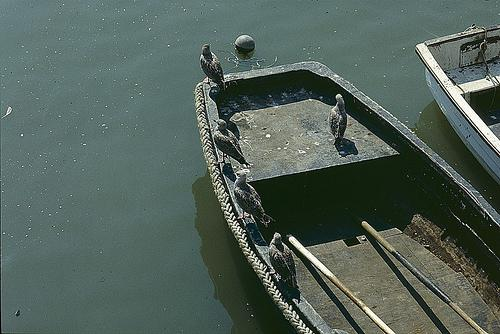Question: what type of vehicle is pictured?
Choices:
A. Boat.
B. Motorcycle.
C. Toyota.
D. Car.
Answer with the letter. Answer: A Question: where is this picture taken?
Choices:
A. In the air.
B. On the water.
C. On icy floor.
D. In the green pasture.
Answer with the letter. Answer: B Question: how many animals are pictured?
Choices:
A. Five.
B. Two.
C. Three.
D. Four.
Answer with the letter. Answer: A Question: what type of animal is in the picture?
Choices:
A. Serpant.
B. Cat.
C. Bird.
D. Horse.
Answer with the letter. Answer: C Question: how many buoys are pictured?
Choices:
A. 3.
B. 2.
C. 1.
D. 6.
Answer with the letter. Answer: C Question: how many vehicles are pictured?
Choices:
A. 34.
B. 2.
C. 3.
D. 1.
Answer with the letter. Answer: B Question: how many people are pictured?
Choices:
A. 3.
B. 56.
C. 34.
D. None.
Answer with the letter. Answer: D 